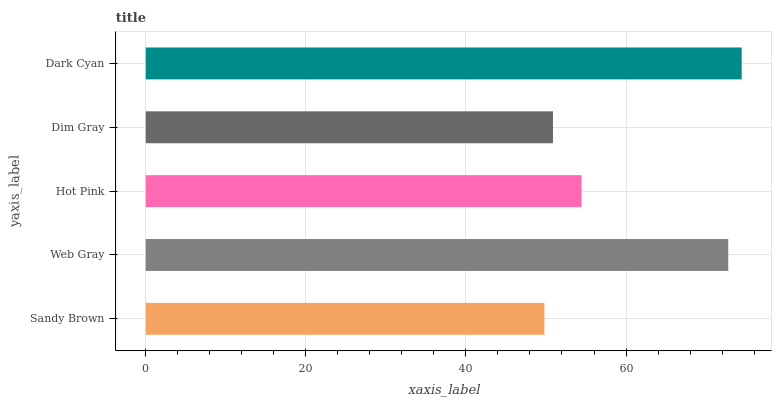Is Sandy Brown the minimum?
Answer yes or no. Yes. Is Dark Cyan the maximum?
Answer yes or no. Yes. Is Web Gray the minimum?
Answer yes or no. No. Is Web Gray the maximum?
Answer yes or no. No. Is Web Gray greater than Sandy Brown?
Answer yes or no. Yes. Is Sandy Brown less than Web Gray?
Answer yes or no. Yes. Is Sandy Brown greater than Web Gray?
Answer yes or no. No. Is Web Gray less than Sandy Brown?
Answer yes or no. No. Is Hot Pink the high median?
Answer yes or no. Yes. Is Hot Pink the low median?
Answer yes or no. Yes. Is Dark Cyan the high median?
Answer yes or no. No. Is Web Gray the low median?
Answer yes or no. No. 